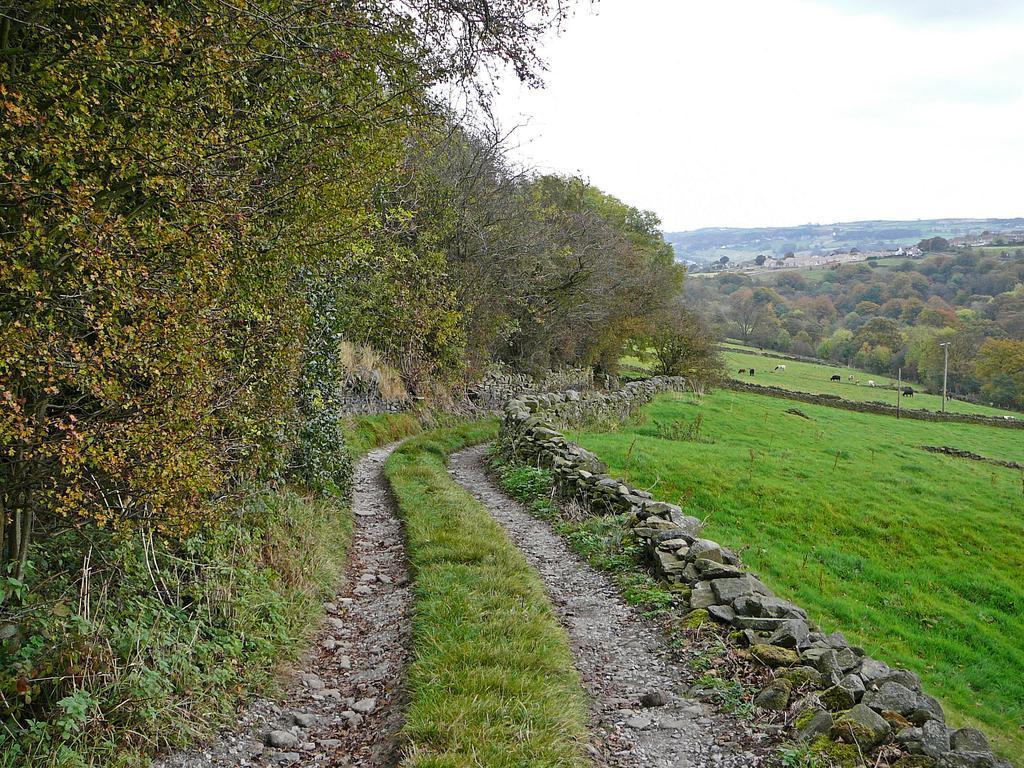In one or two sentences, can you explain what this image depicts? In this picture we can see the farmland. On the right we can see some animals who are eating the grass. On the left we can see the trees. In the background we can see the mountains and buildings. At the top we can see sky and clouds. At the bottom we can see the stones. 